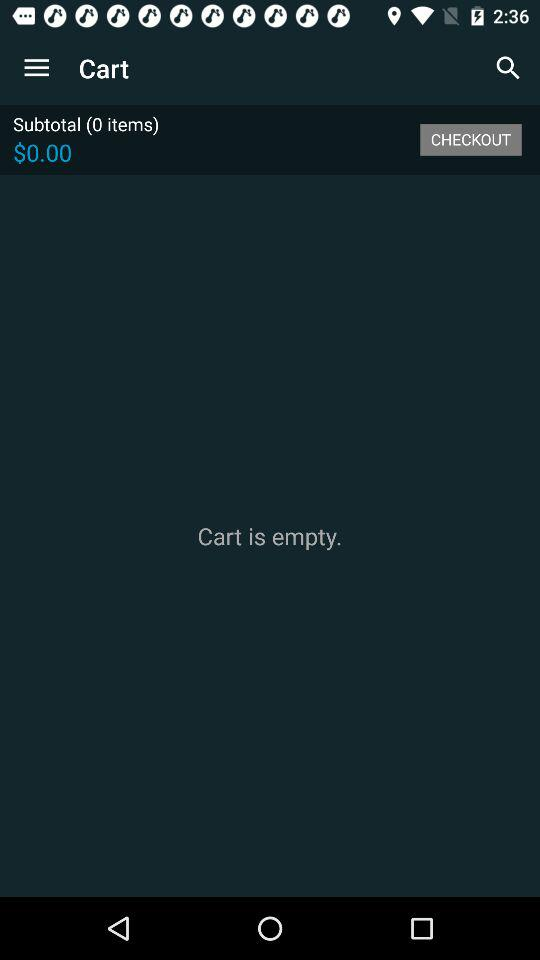What is the "Subtotal" price shown? The "Subtotal" price is $0.00. 